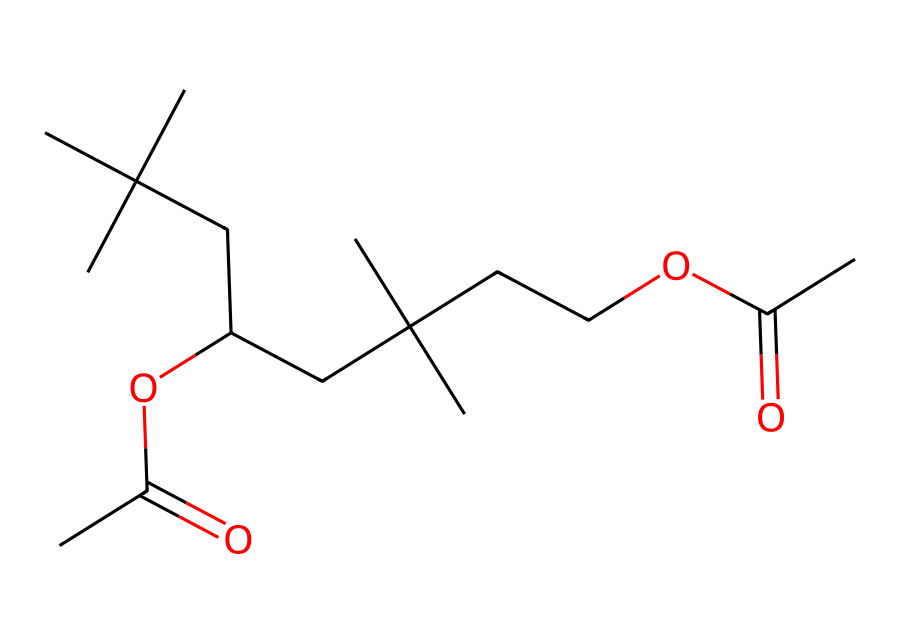What is the total number of carbon atoms in the structure? Counting the carbon (C) atoms in the provided SMILES representation, we identify each 'C' followed by parentheses indicating branching. In total, there are 20 carbon atoms.
Answer: 20 How many ester groups are present in this chemical structure? An ester group is characterized by the presence of a carbonyl (C=O) adjacent to an ether (C-O) moiety. Analyzing the SMILES representation, there are two instances of OC(C)=O indicating two ester groups.
Answer: 2 What type of polymer does this chemical likely represent in helmet padding? The chemical structure includes repeating units connected by ester bonds, indicative of thermoplastic elastomers, which are common in impact-absorbing materials for helmets.
Answer: thermoplastic elastomers Which functional group contributes to the flexibility in the polymer structure? The presence of ester groups contributes to the flexibility of the polymer by allowing the chains to move past one another more easily compared to rigid structures.
Answer: ester groups What is the degree of branching in the polymer chain? The multiple substituents indicated by the branched aliphatic carbon chains suggest a high degree of branching, enhancing properties such as energy absorption.
Answer: high How many oxygen atoms are in the molecule? The oxygen (O) atoms can be counted from the esters (OC) present and those found in the carbonyls. In total, there are 4 oxygen atoms in the structure.
Answer: 4 